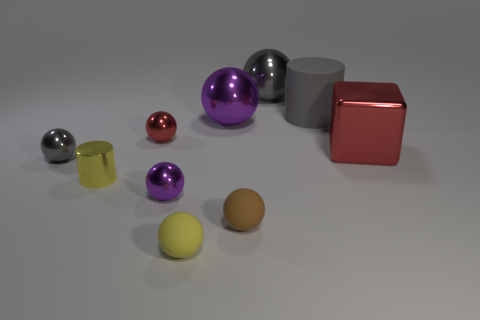Subtract all gray balls. How many balls are left? 5 Subtract all brown balls. How many balls are left? 6 Subtract all gray spheres. Subtract all blue cylinders. How many spheres are left? 5 Subtract all cubes. How many objects are left? 9 Add 5 metallic balls. How many metallic balls are left? 10 Add 6 red spheres. How many red spheres exist? 7 Subtract 1 brown spheres. How many objects are left? 9 Subtract all small brown matte blocks. Subtract all small purple balls. How many objects are left? 9 